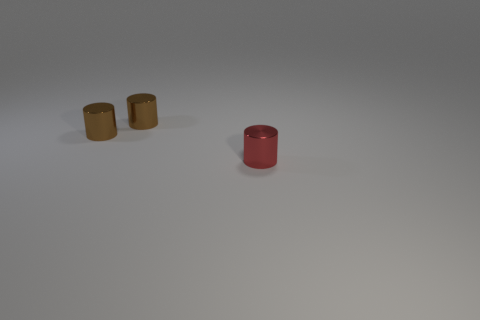Subtract all red metallic cylinders. How many cylinders are left? 2 Subtract all brown cylinders. How many cylinders are left? 1 Add 1 small blue metallic blocks. How many objects exist? 4 Subtract 3 cylinders. How many cylinders are left? 0 Subtract 1 brown cylinders. How many objects are left? 2 Subtract all cyan cylinders. Subtract all brown spheres. How many cylinders are left? 3 Subtract all cyan blocks. How many brown cylinders are left? 2 Subtract all cylinders. Subtract all tiny green shiny blocks. How many objects are left? 0 Add 2 red cylinders. How many red cylinders are left? 3 Add 2 small red objects. How many small red objects exist? 3 